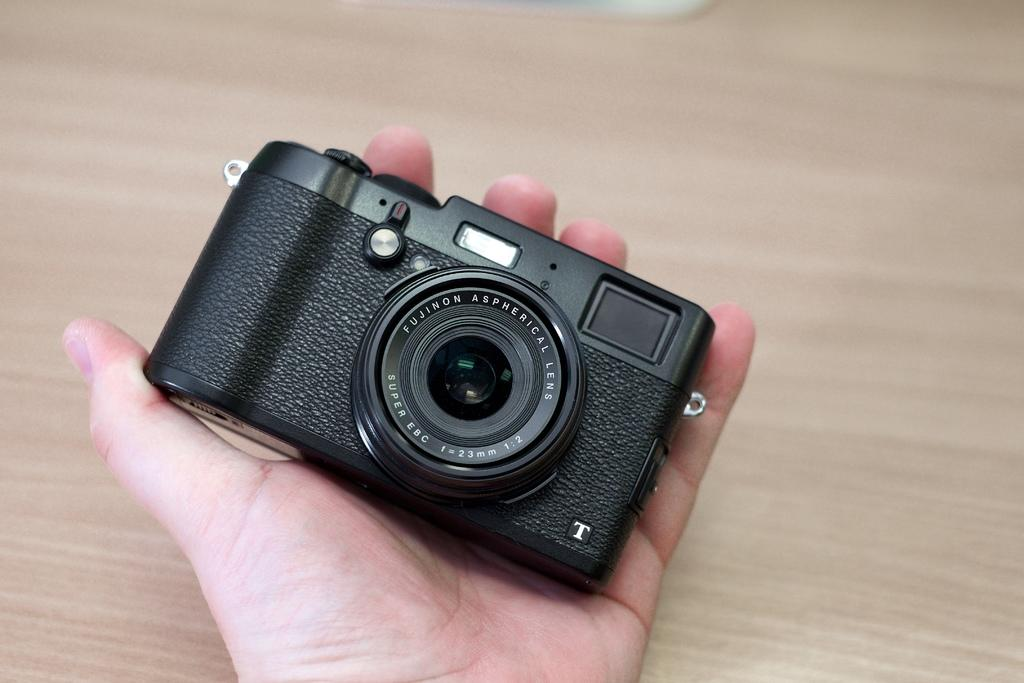What is the main subject of the image? The main subject of the image is a hand. What is the hand holding in the image? The hand is holding a camera. What type of shoes can be seen on the hand in the image? There are no shoes present on the hand in the image; it is holding a camera. What kind of marble is visible on the wall in the image? There is no marble or wall present in the image; it only features a hand holding a camera. 